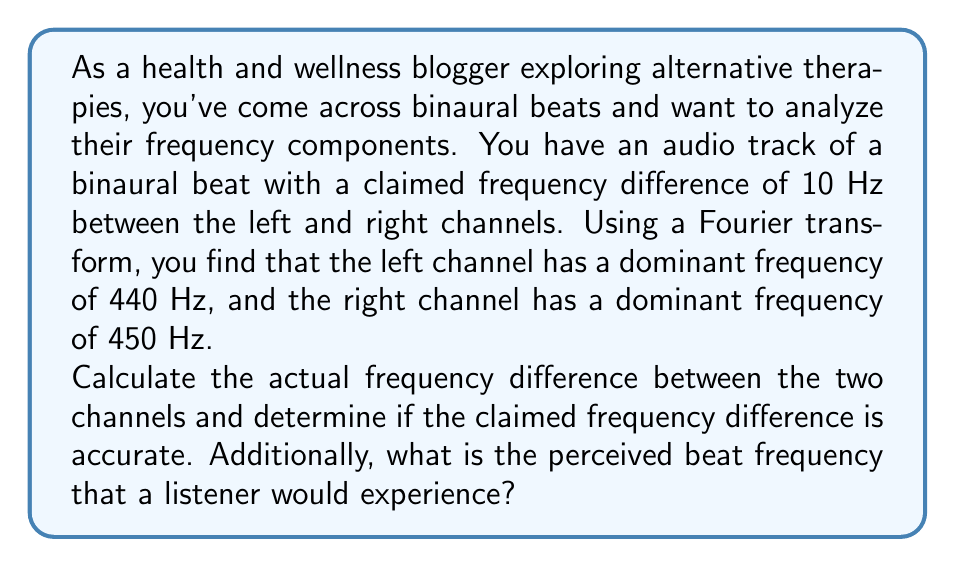Teach me how to tackle this problem. To solve this problem, we need to understand the concept of binaural beats and apply basic frequency analysis:

1. Binaural beats are created when two slightly different frequencies are presented separately to each ear. The brain perceives a beat at the difference between these frequencies.

2. We are given:
   - Left channel dominant frequency: $f_L = 440$ Hz
   - Right channel dominant frequency: $f_R = 450$ Hz
   - Claimed frequency difference: $f_{claimed} = 10$ Hz

3. To calculate the actual frequency difference:
   $$f_{diff} = |f_R - f_L| = |450 \text{ Hz} - 440 \text{ Hz}| = 10 \text{ Hz}$$

4. To determine if the claimed frequency difference is accurate, we compare $f_{diff}$ with $f_{claimed}$:
   $$f_{diff} = f_{claimed} = 10 \text{ Hz}$$
   Therefore, the claimed frequency difference is accurate.

5. The perceived beat frequency is equal to the difference between the two frequencies:
   $$f_{beat} = f_{diff} = 10 \text{ Hz}$$

This means that a listener would perceive a beat frequency of 10 Hz, which falls within the theta brainwave range (4-8 Hz) and low alpha range (8-10 Hz). These ranges are often associated with relaxation, meditation, and improved focus in alternative therapy contexts.
Answer: The actual frequency difference is 10 Hz, which matches the claimed frequency difference. The perceived beat frequency that a listener would experience is also 10 Hz. 